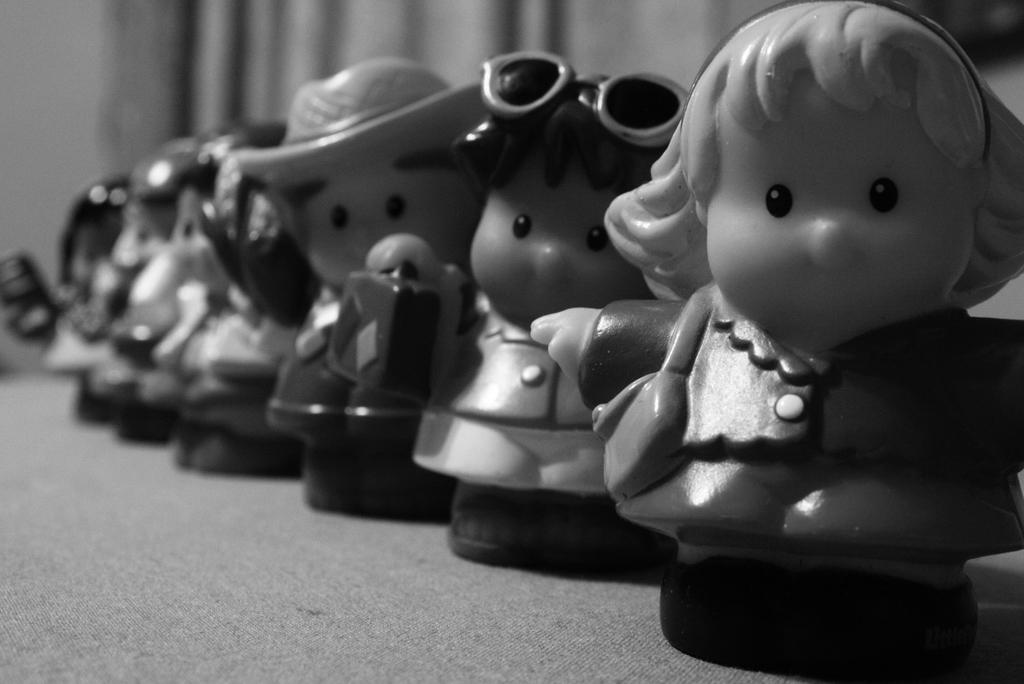What is the color scheme of the image? The image is black and white. What objects can be seen on the table in the image? There are toys placed on a table in the image. What can be seen in the background of the image? There is a curtain in the background of the image. What route does the sail take in the image? There is no sail present in the image, so it is not possible to determine a route. 